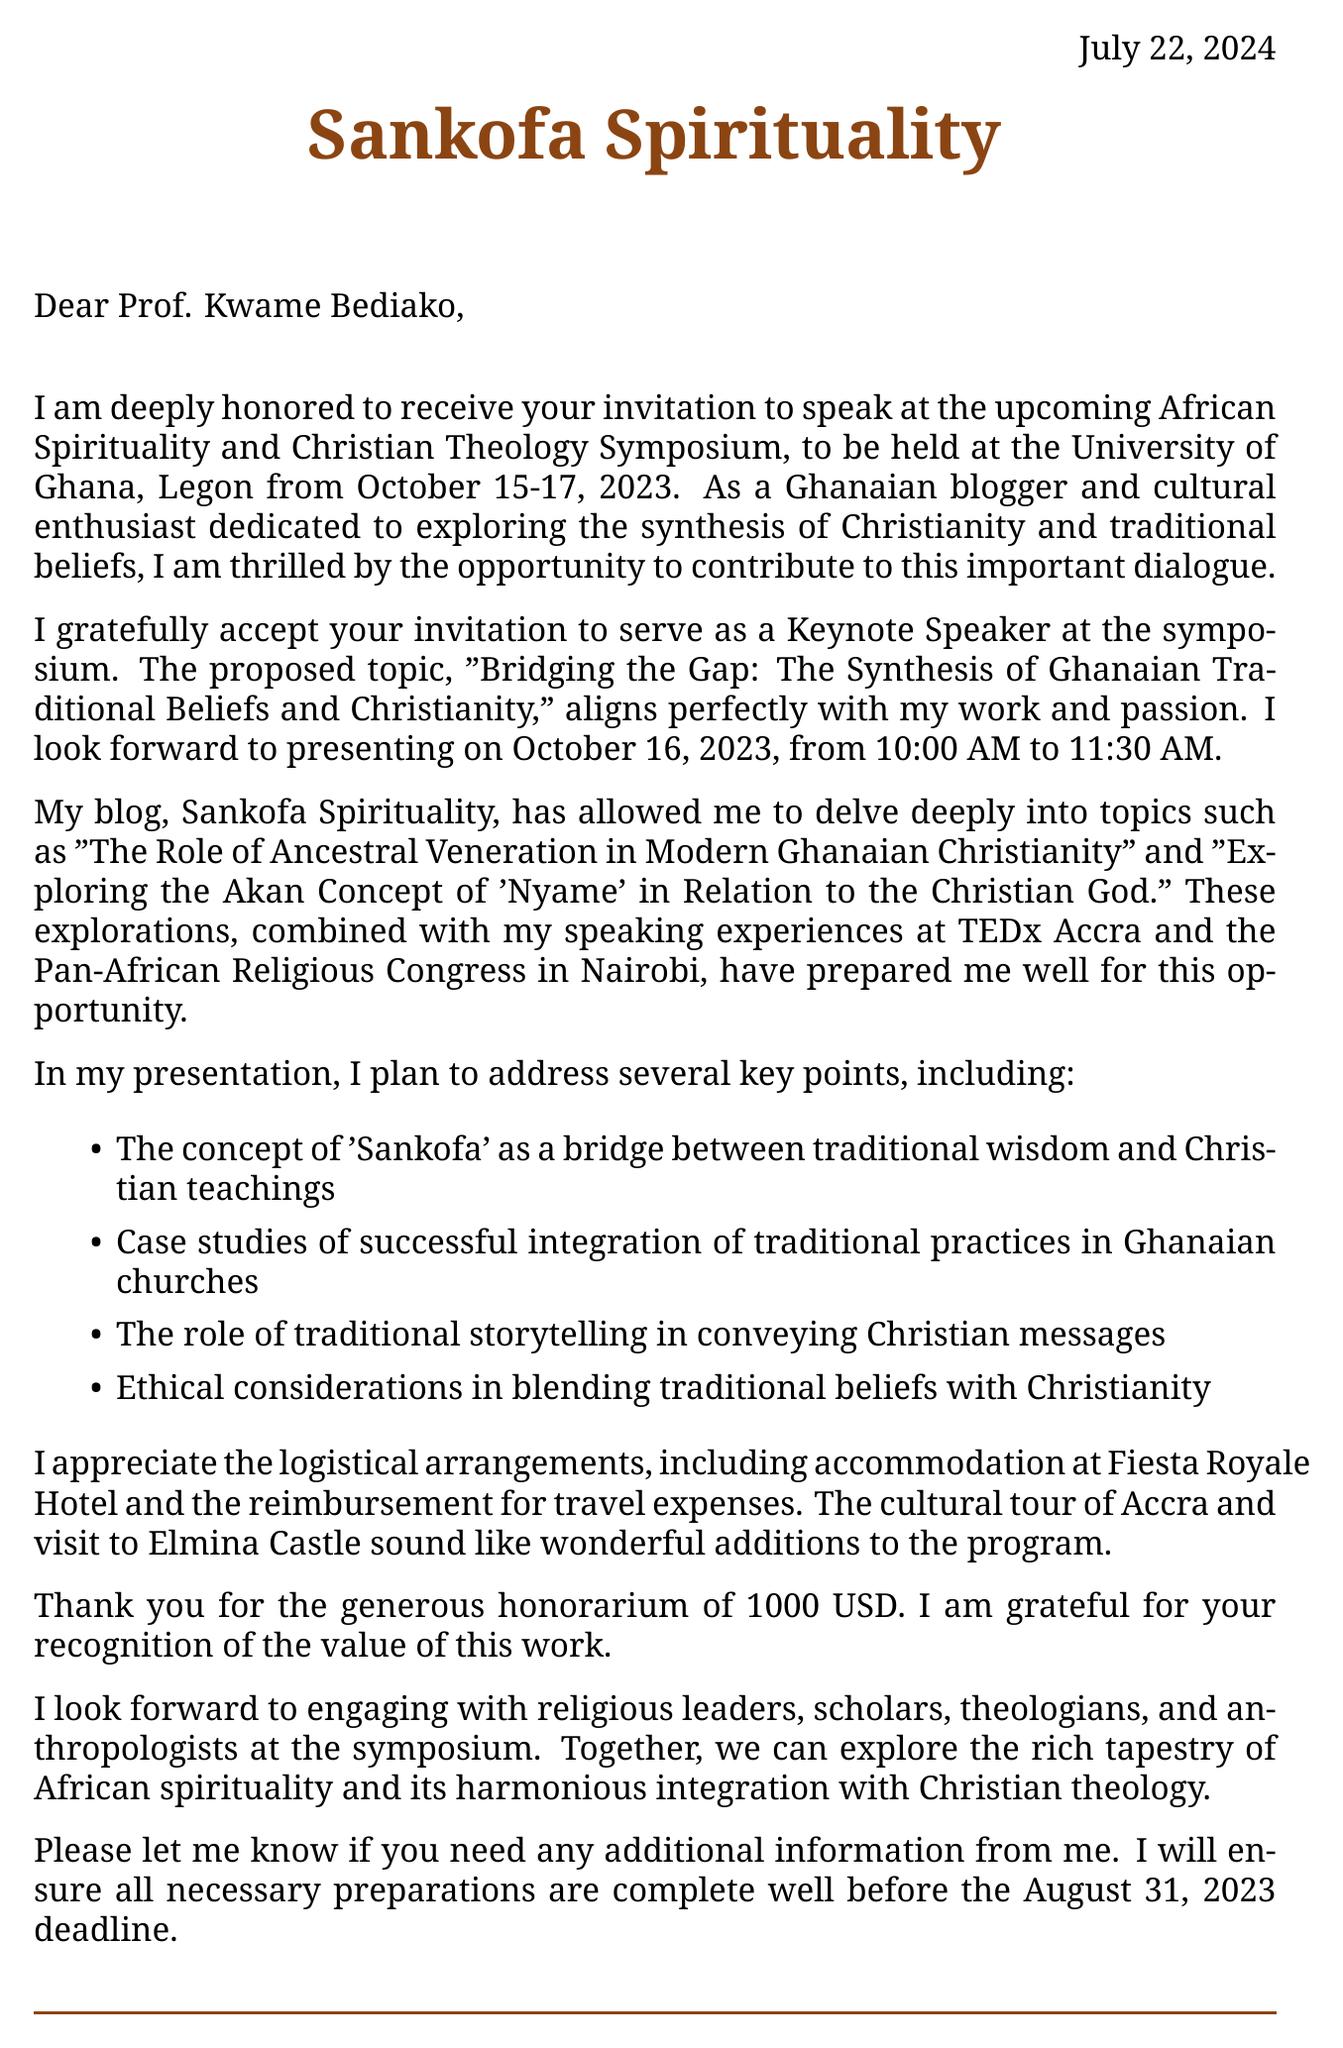What are the dates of the conference? The document states the conference will be held from October 15-17, 2023.
Answer: October 15-17, 2023 Who invited the speaker? The invitation was extended by Prof. Kwame Bediako, mentioned in the document.
Answer: Prof. Kwame Bediako What is the honorarium for the speaker? The document specifies a generous honorarium of 1000 USD for the speaker's engagement.
Answer: 1000 USD What is the main topic of the keynote speech? The document outlines the proposed topic of the keynote speech as "Bridging the Gap: The Synthesis of Ghanaian Traditional Beliefs and Christianity."
Answer: Bridging the Gap: The Synthesis of Ghanaian Traditional Beliefs and Christianity What accommodation is provided for the conference? The document notes that accommodation will be provided at Fiesta Royale Hotel, Accra.
Answer: Fiesta Royale Hotel What type of professionals are expected to attend the symposium? The document lists religious leaders, scholars, theologians, and cultural anthropologists as expected attendees.
Answer: Religious leaders, scholars, theologians, cultural anthropologists What is the speaking slot for the keynote address? The document specifies the speaking slot as October 16, 2023, from 10:00 AM to 11:30 AM.
Answer: October 16, 2023, 10:00 AM - 11:30 AM What is a key talking point mentioned in the document? The document lists "The concept of 'Sankofa' as a bridge between traditional wisdom and Christian teachings" as a key talking point.
Answer: The concept of 'Sankofa' as a bridge between traditional wisdom and Christian teachings 